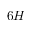Convert formula to latex. <formula><loc_0><loc_0><loc_500><loc_500>6 H</formula> 